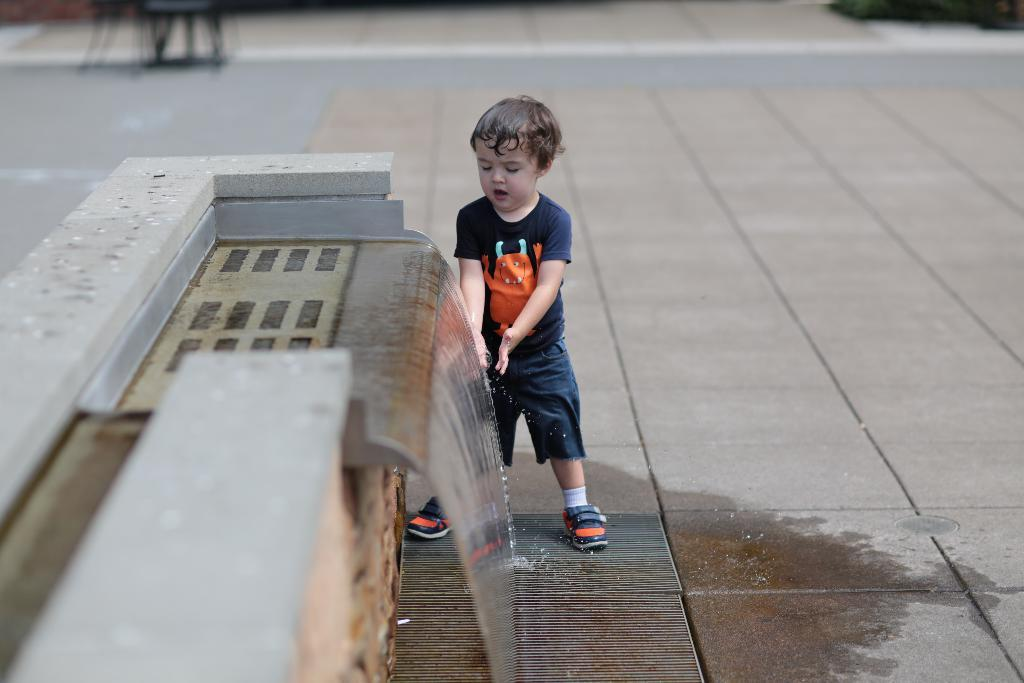Who is present in the image? There is a boy in the image. What is the boy standing near? The boy is standing near an artificial waterfall fountain. Can you describe the background of the image? The background of the image is blurred. How does the boy maintain quiet in the image? The image does not provide information about the boy's actions or the presence of any noise, so it cannot be determined if he is maintaining quiet. 